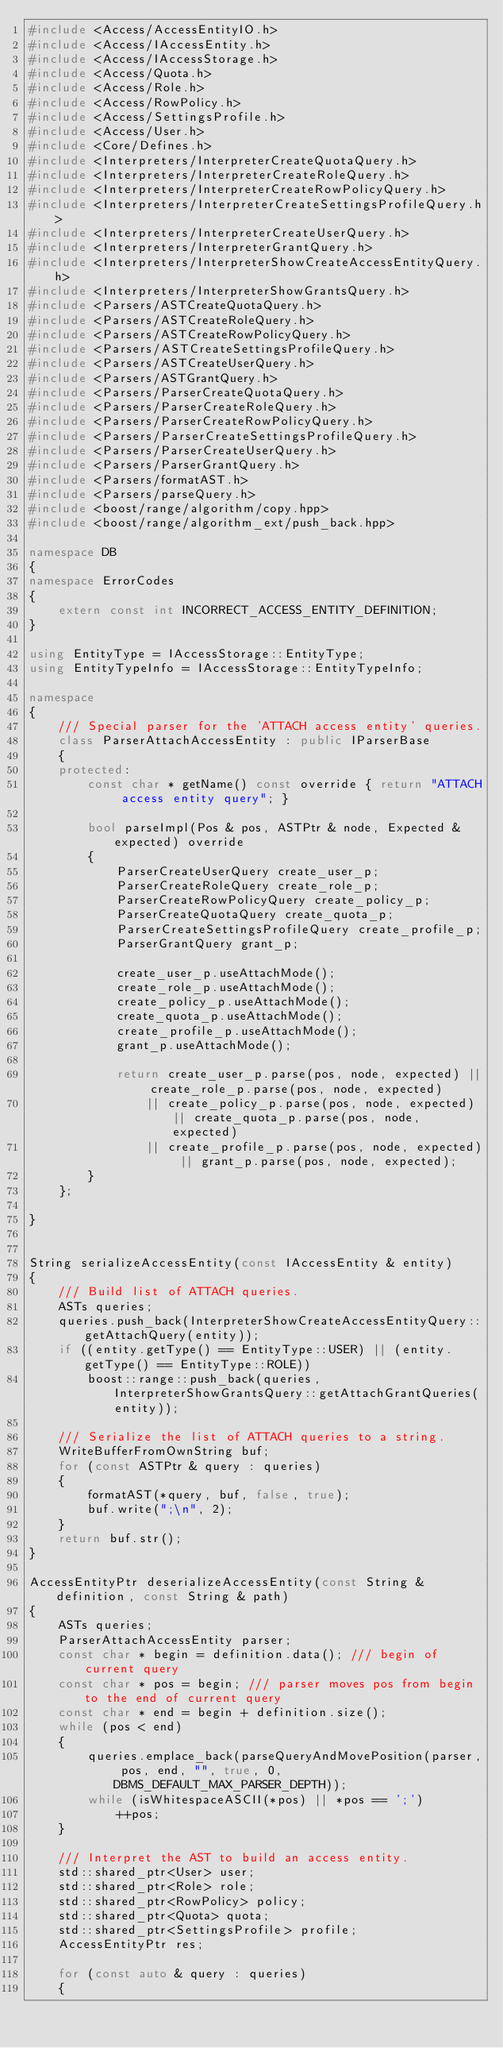<code> <loc_0><loc_0><loc_500><loc_500><_C++_>#include <Access/AccessEntityIO.h>
#include <Access/IAccessEntity.h>
#include <Access/IAccessStorage.h>
#include <Access/Quota.h>
#include <Access/Role.h>
#include <Access/RowPolicy.h>
#include <Access/SettingsProfile.h>
#include <Access/User.h>
#include <Core/Defines.h>
#include <Interpreters/InterpreterCreateQuotaQuery.h>
#include <Interpreters/InterpreterCreateRoleQuery.h>
#include <Interpreters/InterpreterCreateRowPolicyQuery.h>
#include <Interpreters/InterpreterCreateSettingsProfileQuery.h>
#include <Interpreters/InterpreterCreateUserQuery.h>
#include <Interpreters/InterpreterGrantQuery.h>
#include <Interpreters/InterpreterShowCreateAccessEntityQuery.h>
#include <Interpreters/InterpreterShowGrantsQuery.h>
#include <Parsers/ASTCreateQuotaQuery.h>
#include <Parsers/ASTCreateRoleQuery.h>
#include <Parsers/ASTCreateRowPolicyQuery.h>
#include <Parsers/ASTCreateSettingsProfileQuery.h>
#include <Parsers/ASTCreateUserQuery.h>
#include <Parsers/ASTGrantQuery.h>
#include <Parsers/ParserCreateQuotaQuery.h>
#include <Parsers/ParserCreateRoleQuery.h>
#include <Parsers/ParserCreateRowPolicyQuery.h>
#include <Parsers/ParserCreateSettingsProfileQuery.h>
#include <Parsers/ParserCreateUserQuery.h>
#include <Parsers/ParserGrantQuery.h>
#include <Parsers/formatAST.h>
#include <Parsers/parseQuery.h>
#include <boost/range/algorithm/copy.hpp>
#include <boost/range/algorithm_ext/push_back.hpp>

namespace DB
{
namespace ErrorCodes
{
    extern const int INCORRECT_ACCESS_ENTITY_DEFINITION;
}

using EntityType = IAccessStorage::EntityType;
using EntityTypeInfo = IAccessStorage::EntityTypeInfo;

namespace
{
    /// Special parser for the 'ATTACH access entity' queries.
    class ParserAttachAccessEntity : public IParserBase
    {
    protected:
        const char * getName() const override { return "ATTACH access entity query"; }

        bool parseImpl(Pos & pos, ASTPtr & node, Expected & expected) override
        {
            ParserCreateUserQuery create_user_p;
            ParserCreateRoleQuery create_role_p;
            ParserCreateRowPolicyQuery create_policy_p;
            ParserCreateQuotaQuery create_quota_p;
            ParserCreateSettingsProfileQuery create_profile_p;
            ParserGrantQuery grant_p;

            create_user_p.useAttachMode();
            create_role_p.useAttachMode();
            create_policy_p.useAttachMode();
            create_quota_p.useAttachMode();
            create_profile_p.useAttachMode();
            grant_p.useAttachMode();

            return create_user_p.parse(pos, node, expected) || create_role_p.parse(pos, node, expected)
                || create_policy_p.parse(pos, node, expected) || create_quota_p.parse(pos, node, expected)
                || create_profile_p.parse(pos, node, expected) || grant_p.parse(pos, node, expected);
        }
    };

}


String serializeAccessEntity(const IAccessEntity & entity)
{
    /// Build list of ATTACH queries.
    ASTs queries;
    queries.push_back(InterpreterShowCreateAccessEntityQuery::getAttachQuery(entity));
    if ((entity.getType() == EntityType::USER) || (entity.getType() == EntityType::ROLE))
        boost::range::push_back(queries, InterpreterShowGrantsQuery::getAttachGrantQueries(entity));

    /// Serialize the list of ATTACH queries to a string.
    WriteBufferFromOwnString buf;
    for (const ASTPtr & query : queries)
    {
        formatAST(*query, buf, false, true);
        buf.write(";\n", 2);
    }
    return buf.str();
}

AccessEntityPtr deserializeAccessEntity(const String & definition, const String & path)
{
    ASTs queries;
    ParserAttachAccessEntity parser;
    const char * begin = definition.data(); /// begin of current query
    const char * pos = begin; /// parser moves pos from begin to the end of current query
    const char * end = begin + definition.size();
    while (pos < end)
    {
        queries.emplace_back(parseQueryAndMovePosition(parser, pos, end, "", true, 0, DBMS_DEFAULT_MAX_PARSER_DEPTH));
        while (isWhitespaceASCII(*pos) || *pos == ';')
            ++pos;
    }

    /// Interpret the AST to build an access entity.
    std::shared_ptr<User> user;
    std::shared_ptr<Role> role;
    std::shared_ptr<RowPolicy> policy;
    std::shared_ptr<Quota> quota;
    std::shared_ptr<SettingsProfile> profile;
    AccessEntityPtr res;

    for (const auto & query : queries)
    {</code> 